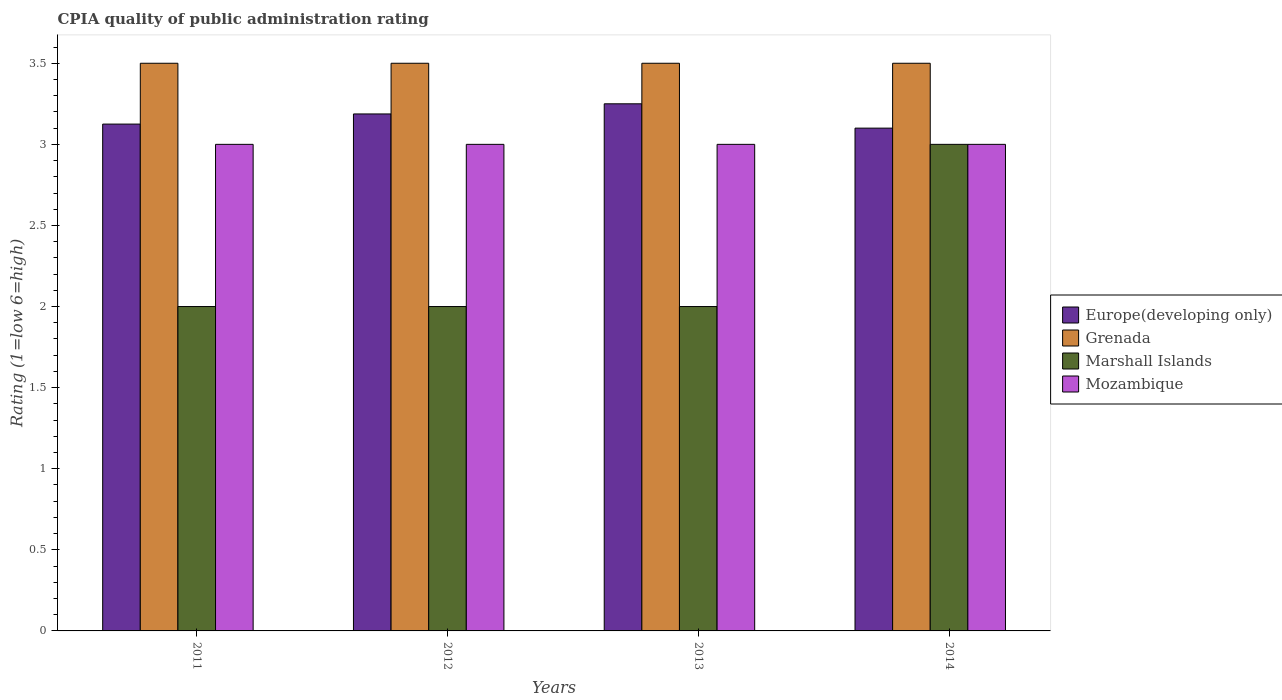How many groups of bars are there?
Give a very brief answer. 4. Are the number of bars on each tick of the X-axis equal?
Offer a terse response. Yes. How many bars are there on the 2nd tick from the left?
Ensure brevity in your answer.  4. How many bars are there on the 2nd tick from the right?
Provide a short and direct response. 4. What is the CPIA rating in Europe(developing only) in 2011?
Your answer should be compact. 3.12. In which year was the CPIA rating in Mozambique minimum?
Give a very brief answer. 2011. What is the total CPIA rating in Mozambique in the graph?
Offer a terse response. 12. What is the difference between the CPIA rating in Europe(developing only) in 2011 and the CPIA rating in Mozambique in 2013?
Your response must be concise. 0.12. In the year 2014, what is the difference between the CPIA rating in Europe(developing only) and CPIA rating in Marshall Islands?
Make the answer very short. 0.1. In how many years, is the CPIA rating in Europe(developing only) greater than 3.2?
Provide a succinct answer. 1. What is the ratio of the CPIA rating in Marshall Islands in 2011 to that in 2014?
Your answer should be compact. 0.67. What is the difference between the highest and the second highest CPIA rating in Grenada?
Ensure brevity in your answer.  0. What is the difference between the highest and the lowest CPIA rating in Europe(developing only)?
Ensure brevity in your answer.  0.15. Is it the case that in every year, the sum of the CPIA rating in Grenada and CPIA rating in Europe(developing only) is greater than the sum of CPIA rating in Mozambique and CPIA rating in Marshall Islands?
Your response must be concise. Yes. What does the 1st bar from the left in 2012 represents?
Offer a very short reply. Europe(developing only). What does the 1st bar from the right in 2011 represents?
Offer a terse response. Mozambique. Is it the case that in every year, the sum of the CPIA rating in Grenada and CPIA rating in Europe(developing only) is greater than the CPIA rating in Marshall Islands?
Your answer should be very brief. Yes. How many bars are there?
Your answer should be very brief. 16. Are all the bars in the graph horizontal?
Keep it short and to the point. No. What is the difference between two consecutive major ticks on the Y-axis?
Offer a terse response. 0.5. Are the values on the major ticks of Y-axis written in scientific E-notation?
Provide a succinct answer. No. Does the graph contain any zero values?
Offer a terse response. No. How many legend labels are there?
Provide a short and direct response. 4. How are the legend labels stacked?
Make the answer very short. Vertical. What is the title of the graph?
Make the answer very short. CPIA quality of public administration rating. Does "Tunisia" appear as one of the legend labels in the graph?
Your response must be concise. No. What is the label or title of the X-axis?
Provide a succinct answer. Years. What is the label or title of the Y-axis?
Make the answer very short. Rating (1=low 6=high). What is the Rating (1=low 6=high) of Europe(developing only) in 2011?
Make the answer very short. 3.12. What is the Rating (1=low 6=high) of Grenada in 2011?
Provide a succinct answer. 3.5. What is the Rating (1=low 6=high) in Marshall Islands in 2011?
Your response must be concise. 2. What is the Rating (1=low 6=high) of Europe(developing only) in 2012?
Keep it short and to the point. 3.19. What is the Rating (1=low 6=high) in Marshall Islands in 2012?
Your response must be concise. 2. What is the Rating (1=low 6=high) in Marshall Islands in 2013?
Make the answer very short. 2. What is the Rating (1=low 6=high) of Mozambique in 2013?
Your answer should be compact. 3. What is the Rating (1=low 6=high) of Grenada in 2014?
Your answer should be very brief. 3.5. What is the Rating (1=low 6=high) in Marshall Islands in 2014?
Your answer should be very brief. 3. Across all years, what is the maximum Rating (1=low 6=high) of Europe(developing only)?
Offer a very short reply. 3.25. Across all years, what is the maximum Rating (1=low 6=high) of Grenada?
Provide a succinct answer. 3.5. Across all years, what is the minimum Rating (1=low 6=high) of Grenada?
Offer a very short reply. 3.5. What is the total Rating (1=low 6=high) in Europe(developing only) in the graph?
Your answer should be very brief. 12.66. What is the total Rating (1=low 6=high) in Grenada in the graph?
Your answer should be compact. 14. What is the total Rating (1=low 6=high) in Marshall Islands in the graph?
Ensure brevity in your answer.  9. What is the total Rating (1=low 6=high) in Mozambique in the graph?
Make the answer very short. 12. What is the difference between the Rating (1=low 6=high) of Europe(developing only) in 2011 and that in 2012?
Ensure brevity in your answer.  -0.06. What is the difference between the Rating (1=low 6=high) in Marshall Islands in 2011 and that in 2012?
Provide a succinct answer. 0. What is the difference between the Rating (1=low 6=high) of Europe(developing only) in 2011 and that in 2013?
Your answer should be very brief. -0.12. What is the difference between the Rating (1=low 6=high) in Marshall Islands in 2011 and that in 2013?
Offer a very short reply. 0. What is the difference between the Rating (1=low 6=high) in Europe(developing only) in 2011 and that in 2014?
Provide a succinct answer. 0.03. What is the difference between the Rating (1=low 6=high) in Marshall Islands in 2011 and that in 2014?
Make the answer very short. -1. What is the difference between the Rating (1=low 6=high) in Europe(developing only) in 2012 and that in 2013?
Make the answer very short. -0.06. What is the difference between the Rating (1=low 6=high) of Europe(developing only) in 2012 and that in 2014?
Offer a terse response. 0.09. What is the difference between the Rating (1=low 6=high) in Grenada in 2012 and that in 2014?
Your answer should be very brief. 0. What is the difference between the Rating (1=low 6=high) in Marshall Islands in 2012 and that in 2014?
Provide a succinct answer. -1. What is the difference between the Rating (1=low 6=high) in Europe(developing only) in 2013 and that in 2014?
Your response must be concise. 0.15. What is the difference between the Rating (1=low 6=high) of Grenada in 2013 and that in 2014?
Your response must be concise. 0. What is the difference between the Rating (1=low 6=high) in Marshall Islands in 2013 and that in 2014?
Provide a short and direct response. -1. What is the difference between the Rating (1=low 6=high) of Mozambique in 2013 and that in 2014?
Your answer should be very brief. 0. What is the difference between the Rating (1=low 6=high) of Europe(developing only) in 2011 and the Rating (1=low 6=high) of Grenada in 2012?
Your answer should be very brief. -0.38. What is the difference between the Rating (1=low 6=high) of Europe(developing only) in 2011 and the Rating (1=low 6=high) of Mozambique in 2012?
Make the answer very short. 0.12. What is the difference between the Rating (1=low 6=high) in Grenada in 2011 and the Rating (1=low 6=high) in Marshall Islands in 2012?
Your answer should be compact. 1.5. What is the difference between the Rating (1=low 6=high) in Grenada in 2011 and the Rating (1=low 6=high) in Mozambique in 2012?
Make the answer very short. 0.5. What is the difference between the Rating (1=low 6=high) in Marshall Islands in 2011 and the Rating (1=low 6=high) in Mozambique in 2012?
Your answer should be compact. -1. What is the difference between the Rating (1=low 6=high) of Europe(developing only) in 2011 and the Rating (1=low 6=high) of Grenada in 2013?
Provide a short and direct response. -0.38. What is the difference between the Rating (1=low 6=high) in Europe(developing only) in 2011 and the Rating (1=low 6=high) in Marshall Islands in 2013?
Give a very brief answer. 1.12. What is the difference between the Rating (1=low 6=high) of Europe(developing only) in 2011 and the Rating (1=low 6=high) of Mozambique in 2013?
Offer a terse response. 0.12. What is the difference between the Rating (1=low 6=high) in Grenada in 2011 and the Rating (1=low 6=high) in Marshall Islands in 2013?
Provide a short and direct response. 1.5. What is the difference between the Rating (1=low 6=high) of Grenada in 2011 and the Rating (1=low 6=high) of Mozambique in 2013?
Your response must be concise. 0.5. What is the difference between the Rating (1=low 6=high) of Marshall Islands in 2011 and the Rating (1=low 6=high) of Mozambique in 2013?
Your answer should be compact. -1. What is the difference between the Rating (1=low 6=high) in Europe(developing only) in 2011 and the Rating (1=low 6=high) in Grenada in 2014?
Make the answer very short. -0.38. What is the difference between the Rating (1=low 6=high) of Europe(developing only) in 2011 and the Rating (1=low 6=high) of Marshall Islands in 2014?
Your answer should be compact. 0.12. What is the difference between the Rating (1=low 6=high) in Grenada in 2011 and the Rating (1=low 6=high) in Mozambique in 2014?
Keep it short and to the point. 0.5. What is the difference between the Rating (1=low 6=high) of Marshall Islands in 2011 and the Rating (1=low 6=high) of Mozambique in 2014?
Ensure brevity in your answer.  -1. What is the difference between the Rating (1=low 6=high) of Europe(developing only) in 2012 and the Rating (1=low 6=high) of Grenada in 2013?
Make the answer very short. -0.31. What is the difference between the Rating (1=low 6=high) of Europe(developing only) in 2012 and the Rating (1=low 6=high) of Marshall Islands in 2013?
Your answer should be compact. 1.19. What is the difference between the Rating (1=low 6=high) in Europe(developing only) in 2012 and the Rating (1=low 6=high) in Mozambique in 2013?
Ensure brevity in your answer.  0.19. What is the difference between the Rating (1=low 6=high) of Marshall Islands in 2012 and the Rating (1=low 6=high) of Mozambique in 2013?
Give a very brief answer. -1. What is the difference between the Rating (1=low 6=high) of Europe(developing only) in 2012 and the Rating (1=low 6=high) of Grenada in 2014?
Your answer should be compact. -0.31. What is the difference between the Rating (1=low 6=high) in Europe(developing only) in 2012 and the Rating (1=low 6=high) in Marshall Islands in 2014?
Give a very brief answer. 0.19. What is the difference between the Rating (1=low 6=high) of Europe(developing only) in 2012 and the Rating (1=low 6=high) of Mozambique in 2014?
Ensure brevity in your answer.  0.19. What is the difference between the Rating (1=low 6=high) of Grenada in 2012 and the Rating (1=low 6=high) of Mozambique in 2014?
Provide a succinct answer. 0.5. What is the difference between the Rating (1=low 6=high) in Europe(developing only) in 2013 and the Rating (1=low 6=high) in Grenada in 2014?
Give a very brief answer. -0.25. What is the difference between the Rating (1=low 6=high) in Europe(developing only) in 2013 and the Rating (1=low 6=high) in Marshall Islands in 2014?
Your answer should be very brief. 0.25. What is the difference between the Rating (1=low 6=high) of Europe(developing only) in 2013 and the Rating (1=low 6=high) of Mozambique in 2014?
Give a very brief answer. 0.25. What is the difference between the Rating (1=low 6=high) of Grenada in 2013 and the Rating (1=low 6=high) of Marshall Islands in 2014?
Your response must be concise. 0.5. What is the difference between the Rating (1=low 6=high) in Grenada in 2013 and the Rating (1=low 6=high) in Mozambique in 2014?
Your response must be concise. 0.5. What is the difference between the Rating (1=low 6=high) in Marshall Islands in 2013 and the Rating (1=low 6=high) in Mozambique in 2014?
Provide a succinct answer. -1. What is the average Rating (1=low 6=high) in Europe(developing only) per year?
Offer a terse response. 3.17. What is the average Rating (1=low 6=high) of Grenada per year?
Make the answer very short. 3.5. What is the average Rating (1=low 6=high) of Marshall Islands per year?
Your response must be concise. 2.25. In the year 2011, what is the difference between the Rating (1=low 6=high) in Europe(developing only) and Rating (1=low 6=high) in Grenada?
Offer a very short reply. -0.38. In the year 2011, what is the difference between the Rating (1=low 6=high) in Europe(developing only) and Rating (1=low 6=high) in Mozambique?
Offer a very short reply. 0.12. In the year 2011, what is the difference between the Rating (1=low 6=high) in Grenada and Rating (1=low 6=high) in Marshall Islands?
Keep it short and to the point. 1.5. In the year 2012, what is the difference between the Rating (1=low 6=high) of Europe(developing only) and Rating (1=low 6=high) of Grenada?
Keep it short and to the point. -0.31. In the year 2012, what is the difference between the Rating (1=low 6=high) of Europe(developing only) and Rating (1=low 6=high) of Marshall Islands?
Your answer should be compact. 1.19. In the year 2012, what is the difference between the Rating (1=low 6=high) of Europe(developing only) and Rating (1=low 6=high) of Mozambique?
Ensure brevity in your answer.  0.19. In the year 2013, what is the difference between the Rating (1=low 6=high) of Grenada and Rating (1=low 6=high) of Marshall Islands?
Your response must be concise. 1.5. In the year 2013, what is the difference between the Rating (1=low 6=high) of Marshall Islands and Rating (1=low 6=high) of Mozambique?
Provide a short and direct response. -1. In the year 2014, what is the difference between the Rating (1=low 6=high) in Europe(developing only) and Rating (1=low 6=high) in Mozambique?
Offer a terse response. 0.1. What is the ratio of the Rating (1=low 6=high) of Europe(developing only) in 2011 to that in 2012?
Your response must be concise. 0.98. What is the ratio of the Rating (1=low 6=high) of Grenada in 2011 to that in 2012?
Your response must be concise. 1. What is the ratio of the Rating (1=low 6=high) in Europe(developing only) in 2011 to that in 2013?
Offer a very short reply. 0.96. What is the ratio of the Rating (1=low 6=high) in Grenada in 2011 to that in 2013?
Provide a short and direct response. 1. What is the ratio of the Rating (1=low 6=high) in Marshall Islands in 2011 to that in 2013?
Your response must be concise. 1. What is the ratio of the Rating (1=low 6=high) in Grenada in 2011 to that in 2014?
Give a very brief answer. 1. What is the ratio of the Rating (1=low 6=high) of Mozambique in 2011 to that in 2014?
Provide a short and direct response. 1. What is the ratio of the Rating (1=low 6=high) of Europe(developing only) in 2012 to that in 2013?
Keep it short and to the point. 0.98. What is the ratio of the Rating (1=low 6=high) in Grenada in 2012 to that in 2013?
Your response must be concise. 1. What is the ratio of the Rating (1=low 6=high) in Europe(developing only) in 2012 to that in 2014?
Ensure brevity in your answer.  1.03. What is the ratio of the Rating (1=low 6=high) in Mozambique in 2012 to that in 2014?
Your answer should be very brief. 1. What is the ratio of the Rating (1=low 6=high) of Europe(developing only) in 2013 to that in 2014?
Your answer should be very brief. 1.05. What is the ratio of the Rating (1=low 6=high) in Grenada in 2013 to that in 2014?
Offer a very short reply. 1. What is the difference between the highest and the second highest Rating (1=low 6=high) in Europe(developing only)?
Your answer should be very brief. 0.06. What is the difference between the highest and the second highest Rating (1=low 6=high) of Grenada?
Offer a very short reply. 0. What is the difference between the highest and the lowest Rating (1=low 6=high) in Marshall Islands?
Your response must be concise. 1. 